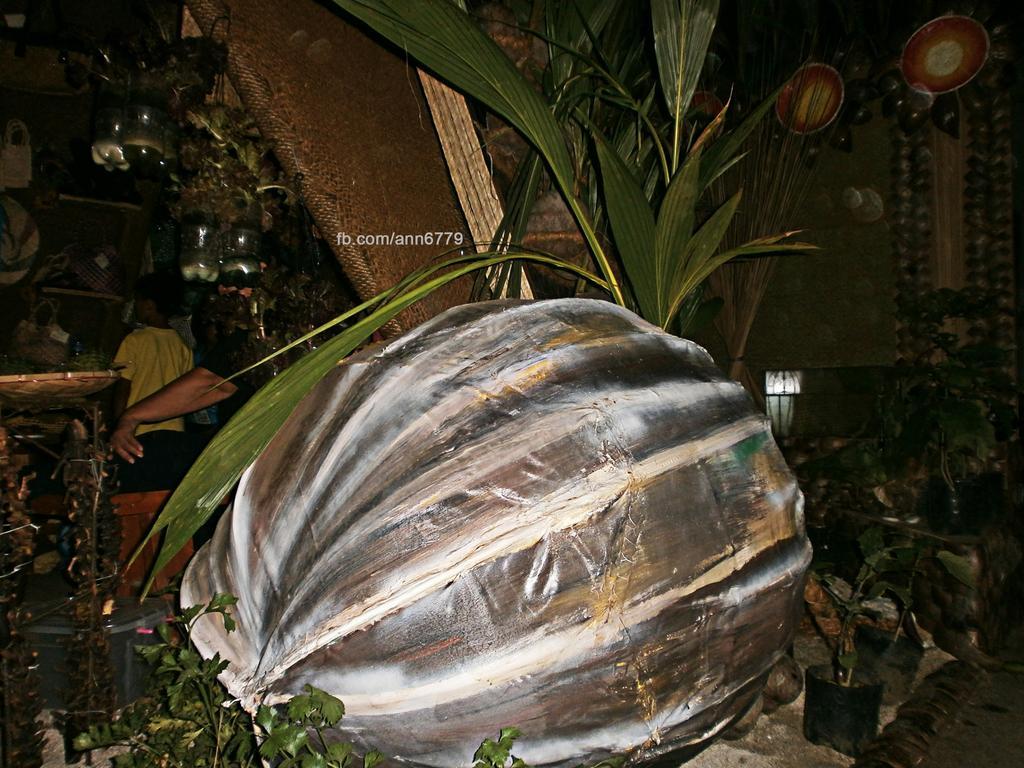Describe this image in one or two sentences. In the foreground of this image, there is an object and few plants. We can also see few bottles with plants are hanging and people in the background. 